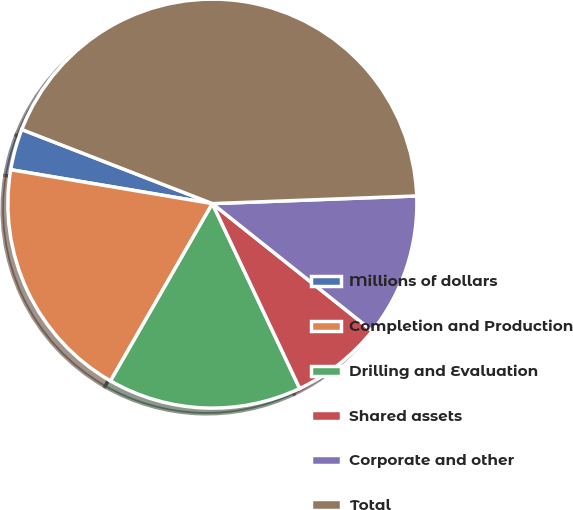Convert chart. <chart><loc_0><loc_0><loc_500><loc_500><pie_chart><fcel>Millions of dollars<fcel>Completion and Production<fcel>Drilling and Evaluation<fcel>Shared assets<fcel>Corporate and other<fcel>Total<nl><fcel>3.25%<fcel>19.35%<fcel>15.32%<fcel>7.27%<fcel>11.3%<fcel>43.5%<nl></chart> 